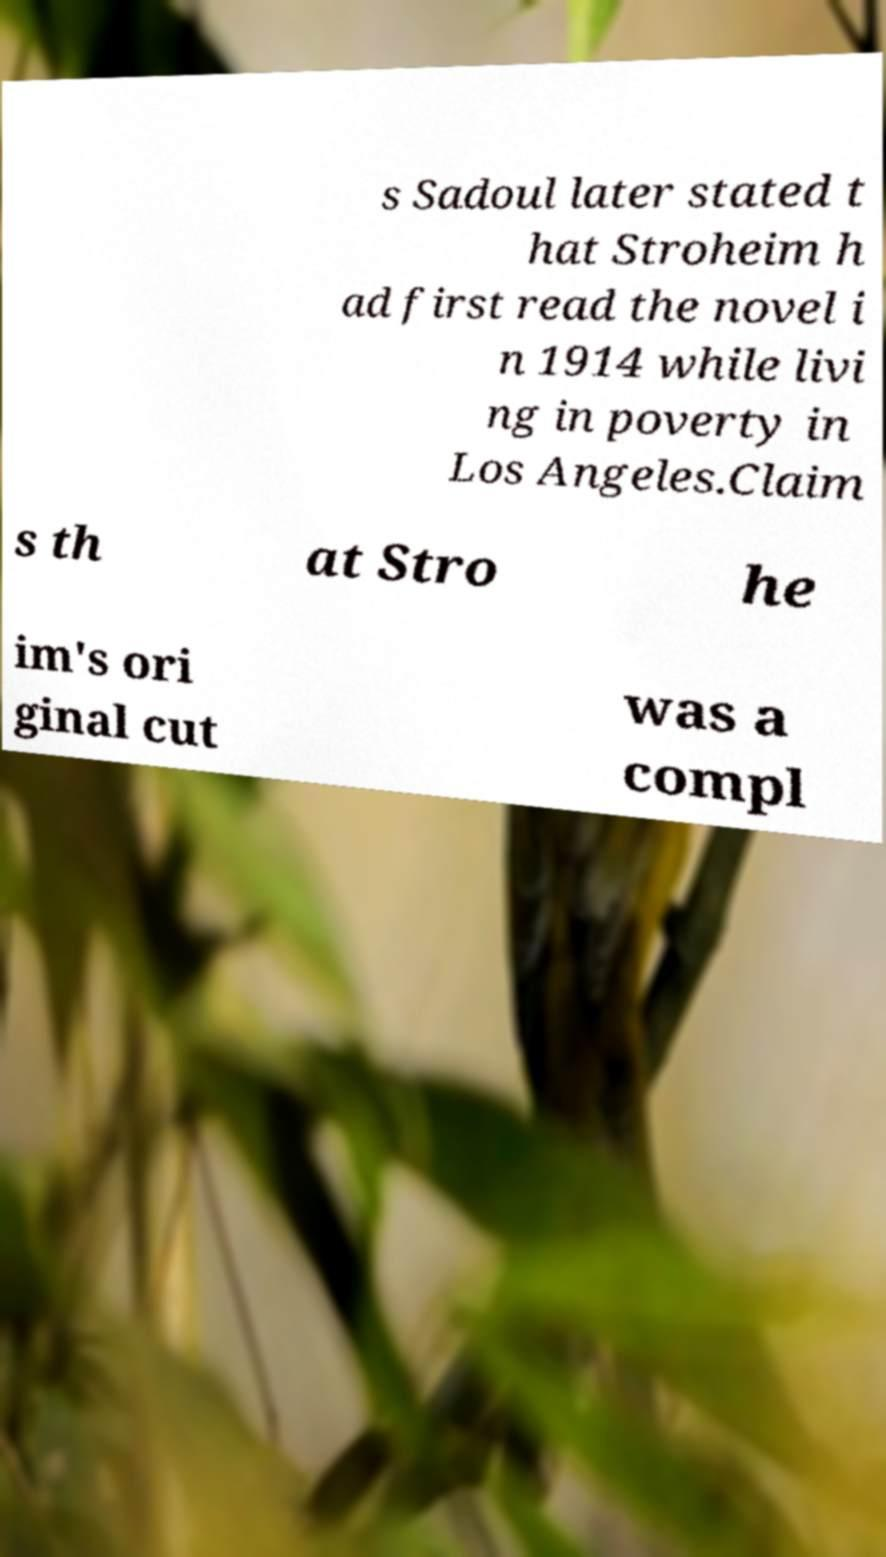Please identify and transcribe the text found in this image. s Sadoul later stated t hat Stroheim h ad first read the novel i n 1914 while livi ng in poverty in Los Angeles.Claim s th at Stro he im's ori ginal cut was a compl 